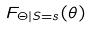<formula> <loc_0><loc_0><loc_500><loc_500>F _ { \Theta | S = s } ( \theta )</formula> 